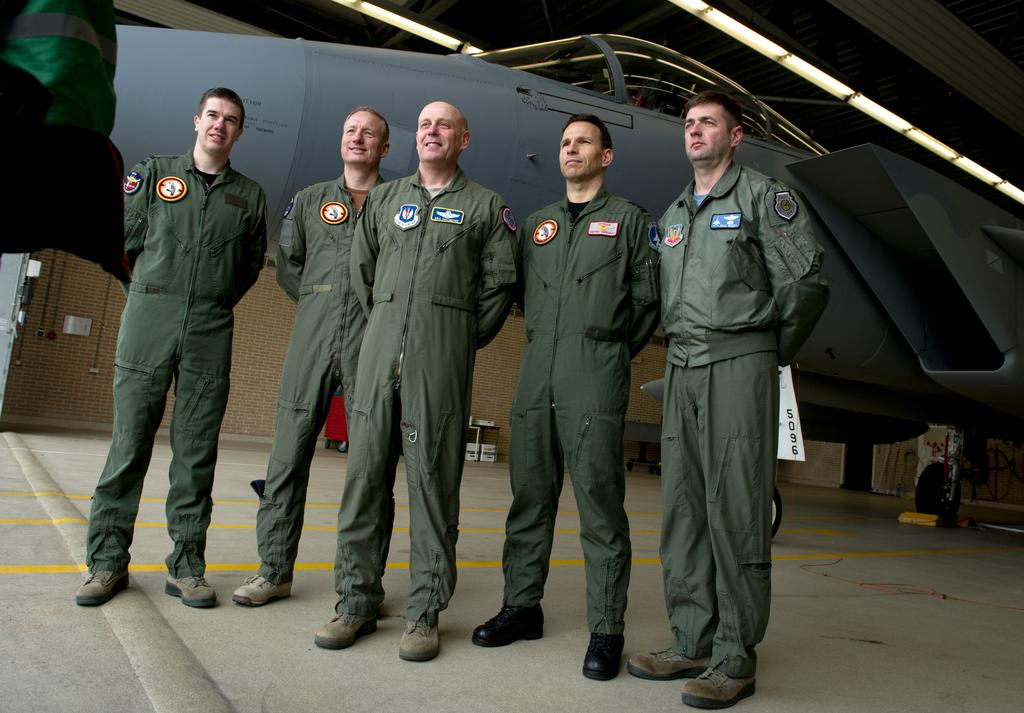How many people are present in the image? There are 5 people in the image. What are the people wearing? The people are wearing uniforms. What can be seen behind the people? There is an aircraft behind the people. What is located at the top of the image? There are lights at the top of the image. How many mice are visible on the arm of the person in the image? There are no mice present in the image, and no one's arm is visible. What type of bike can be seen in the image? There is no bike present in the image. 